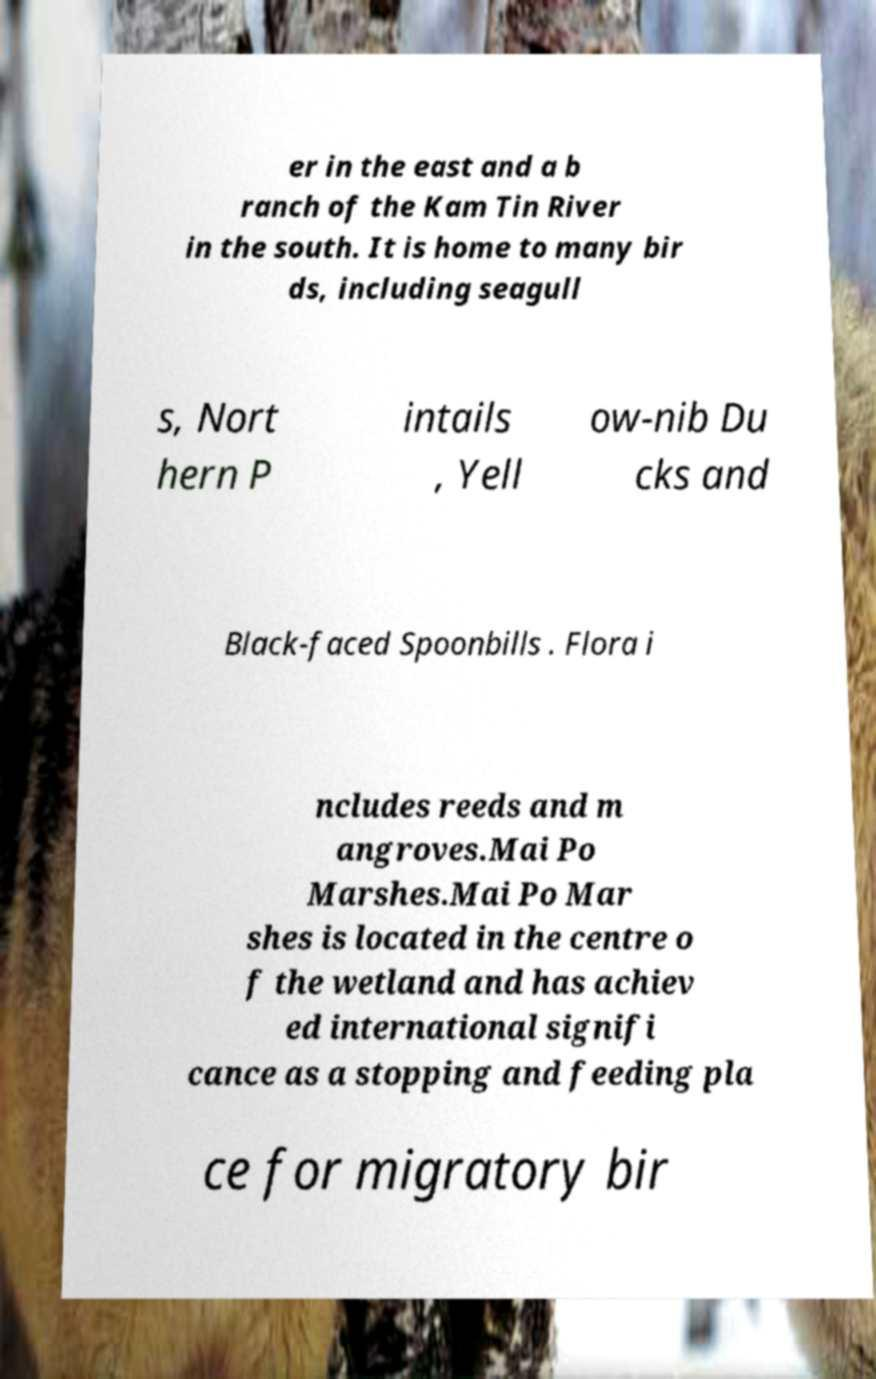For documentation purposes, I need the text within this image transcribed. Could you provide that? er in the east and a b ranch of the Kam Tin River in the south. It is home to many bir ds, including seagull s, Nort hern P intails , Yell ow-nib Du cks and Black-faced Spoonbills . Flora i ncludes reeds and m angroves.Mai Po Marshes.Mai Po Mar shes is located in the centre o f the wetland and has achiev ed international signifi cance as a stopping and feeding pla ce for migratory bir 